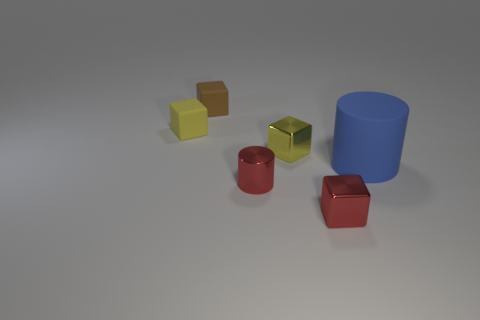What number of yellow objects are to the left of the cylinder that is in front of the blue object?
Your answer should be compact. 1. What material is the brown thing that is the same size as the yellow matte block?
Make the answer very short. Rubber. Does the small yellow object that is on the right side of the red metal cylinder have the same shape as the large blue object?
Keep it short and to the point. No. Is the number of tiny yellow matte objects that are behind the small metallic cylinder greater than the number of tiny red cylinders on the left side of the blue rubber thing?
Provide a short and direct response. No. What number of cylinders have the same material as the tiny red cube?
Provide a succinct answer. 1. Is the size of the red metal cylinder the same as the blue thing?
Your answer should be compact. No. The rubber cylinder is what color?
Your answer should be very brief. Blue. What number of things are either large purple rubber cylinders or red things?
Your answer should be very brief. 2. Is there a metal object of the same shape as the brown rubber object?
Offer a terse response. Yes. There is a block that is in front of the red metal cylinder; is it the same color as the small cylinder?
Offer a terse response. Yes. 